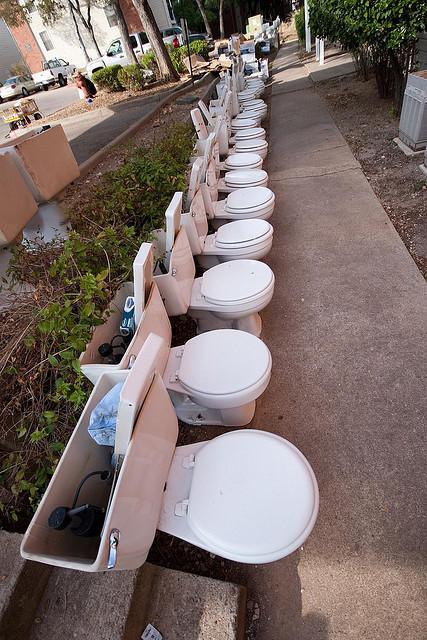What are all the toilets standing on?
Concise answer only. Sidewalk. Are the lids off the toilet seats?
Concise answer only. No. How many toilets are there?
Be succinct. 15. How many urinals are pictured?
Answer briefly. 0. 